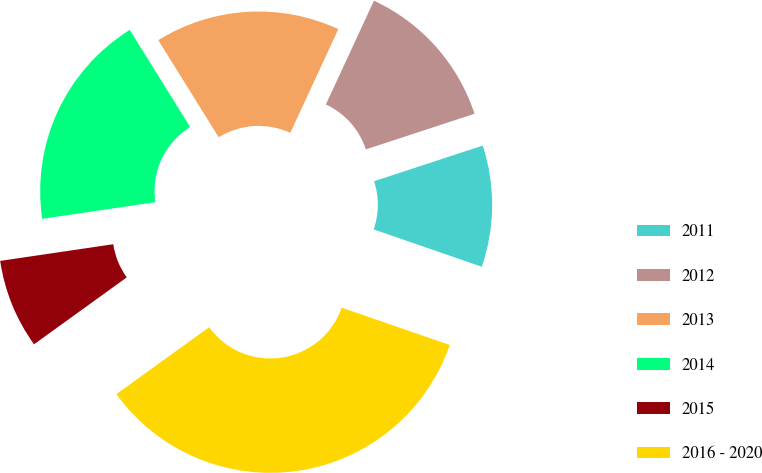<chart> <loc_0><loc_0><loc_500><loc_500><pie_chart><fcel>2011<fcel>2012<fcel>2013<fcel>2014<fcel>2015<fcel>2016 - 2020<nl><fcel>10.34%<fcel>13.05%<fcel>15.76%<fcel>18.48%<fcel>7.62%<fcel>34.76%<nl></chart> 